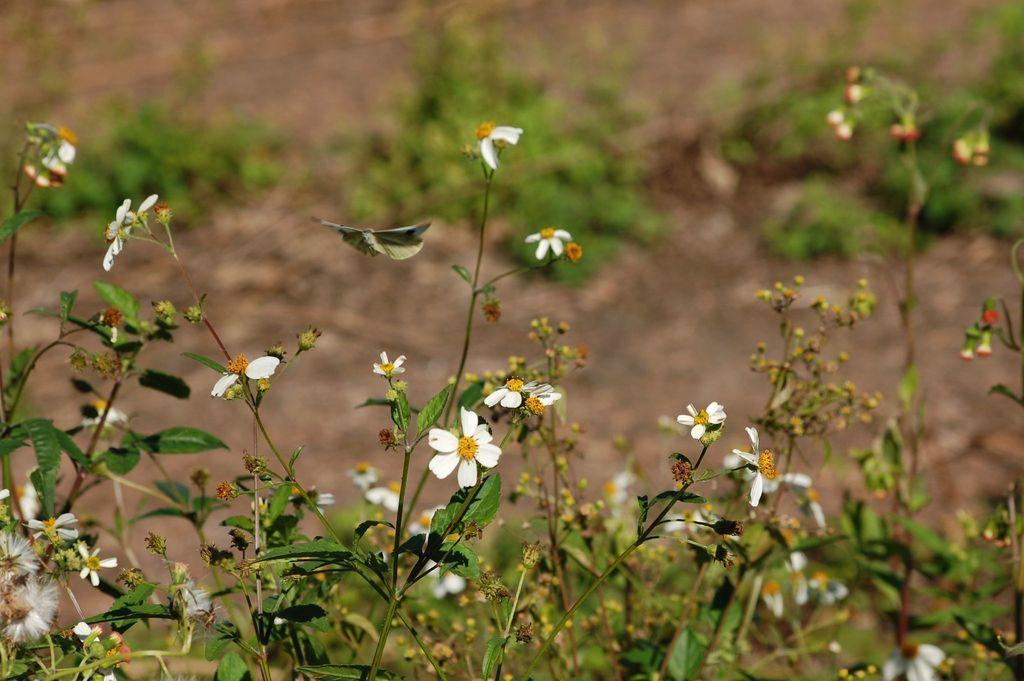Describe this image in one or two sentences. In this image there are plants with small white color flowers. In the background there is soil in which there are few plants. 